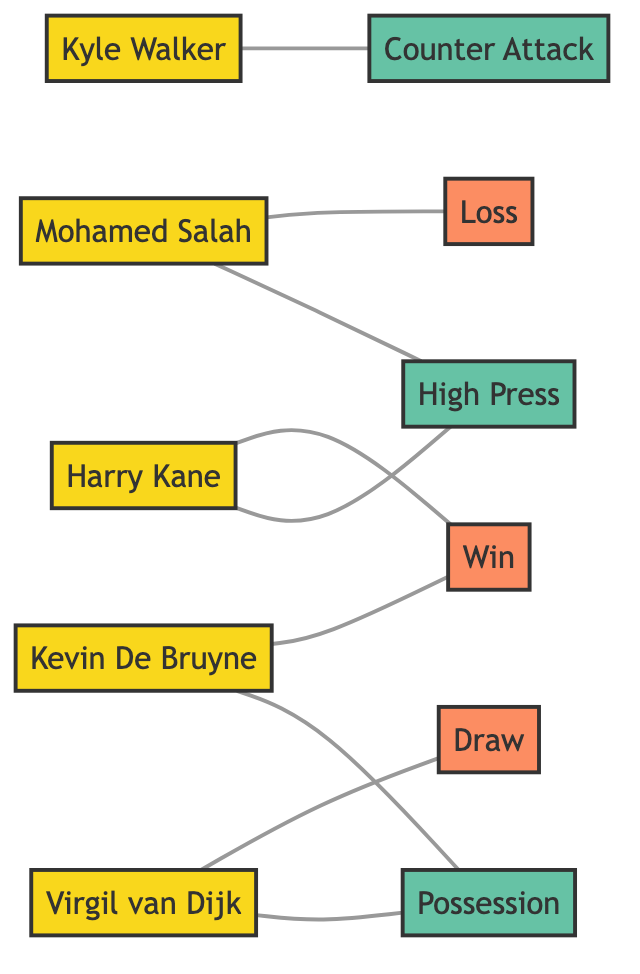What players are associated with the High Press strategy? Two players, Harry Kane and Mohamed Salah, are connected to the High Press strategy in the diagram.
Answer: Harry Kane, Mohamed Salah How many players are in the diagram? The diagram lists five players: Harry Kane, Kyle Walker, Kevin De Bruyne, Virgil van Dijk, and Mohamed Salah. Counting these nodes gives a total of five players.
Answer: 5 What is the outcome associated with Kevin De Bruyne? Kevin De Bruyne is linked to the Winning outcome in the diagram. The relationship indicates that when he is involved, the match outcome can be a win.
Answer: Win Which player is associated with the Counter Attack strategy? The diagram shows that Kyle Walker is the player linked to the Counter Attack strategy, indicating his role in that tactic.
Answer: Kyle Walker What strategy is connected to both Virgil van Dijk and Kevin De Bruyne? Both players are associated with the Possession strategy in the diagram, as it connects them to a common node.
Answer: Possession What is the match outcome for Mohamed Salah? The diagram indicates that the match outcome for Mohamed Salah is a Loss, showing the effect of the strategies he was associated with in matches.
Answer: Loss Which strategy does Harry Kane rely on to achieve a win? Harry Kane is linked to the High Press strategy, which is crucial for facilitating his team's chances of winning matches.
Answer: High Press How many strategies are displayed in the diagram? The diagram contains three strategies: High Press, Counter Attack, and Possession. Counting these strategies results in three distinct strategies visible in the nodes.
Answer: 3 Which outcomes does Virgil van Dijk contribute to? Virgil van Dijk contributes to both the Draw and Possession outcomes, as indicated by the edges connected to him from these nodes.
Answer: Draw, Possession 